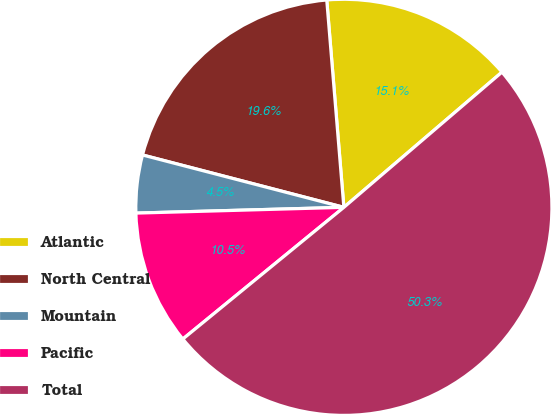Convert chart. <chart><loc_0><loc_0><loc_500><loc_500><pie_chart><fcel>Atlantic<fcel>North Central<fcel>Mountain<fcel>Pacific<fcel>Total<nl><fcel>15.05%<fcel>19.64%<fcel>4.49%<fcel>10.47%<fcel>50.35%<nl></chart> 